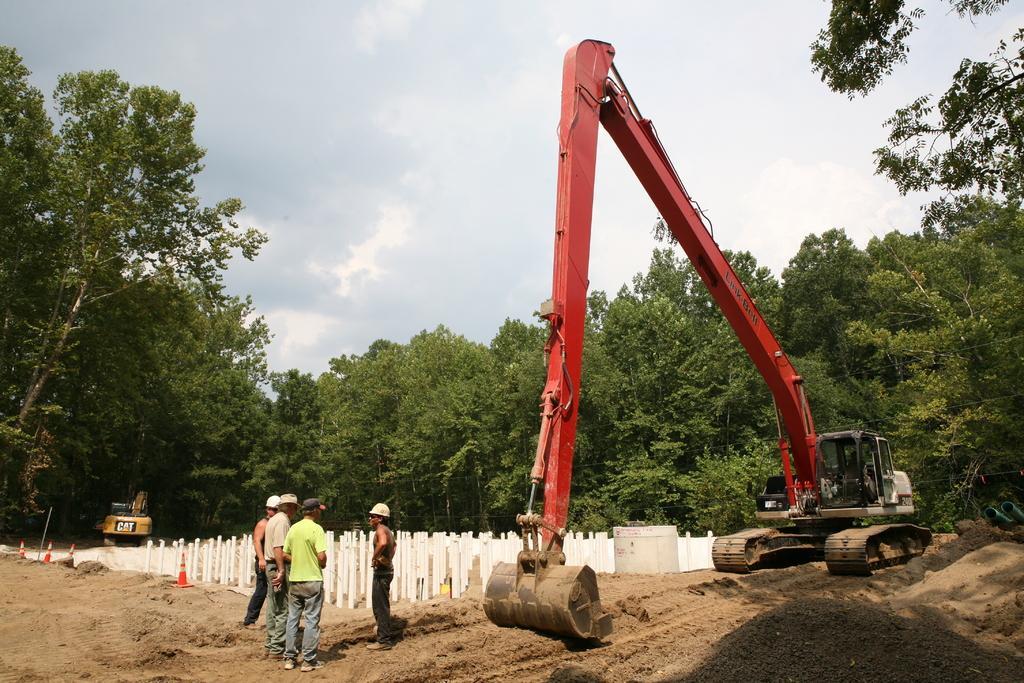Can you describe this image briefly? In this image we can see the cranes on the ground, there are some traffic cones, people, poles and trees, in the background, we can see the sky with clouds. 